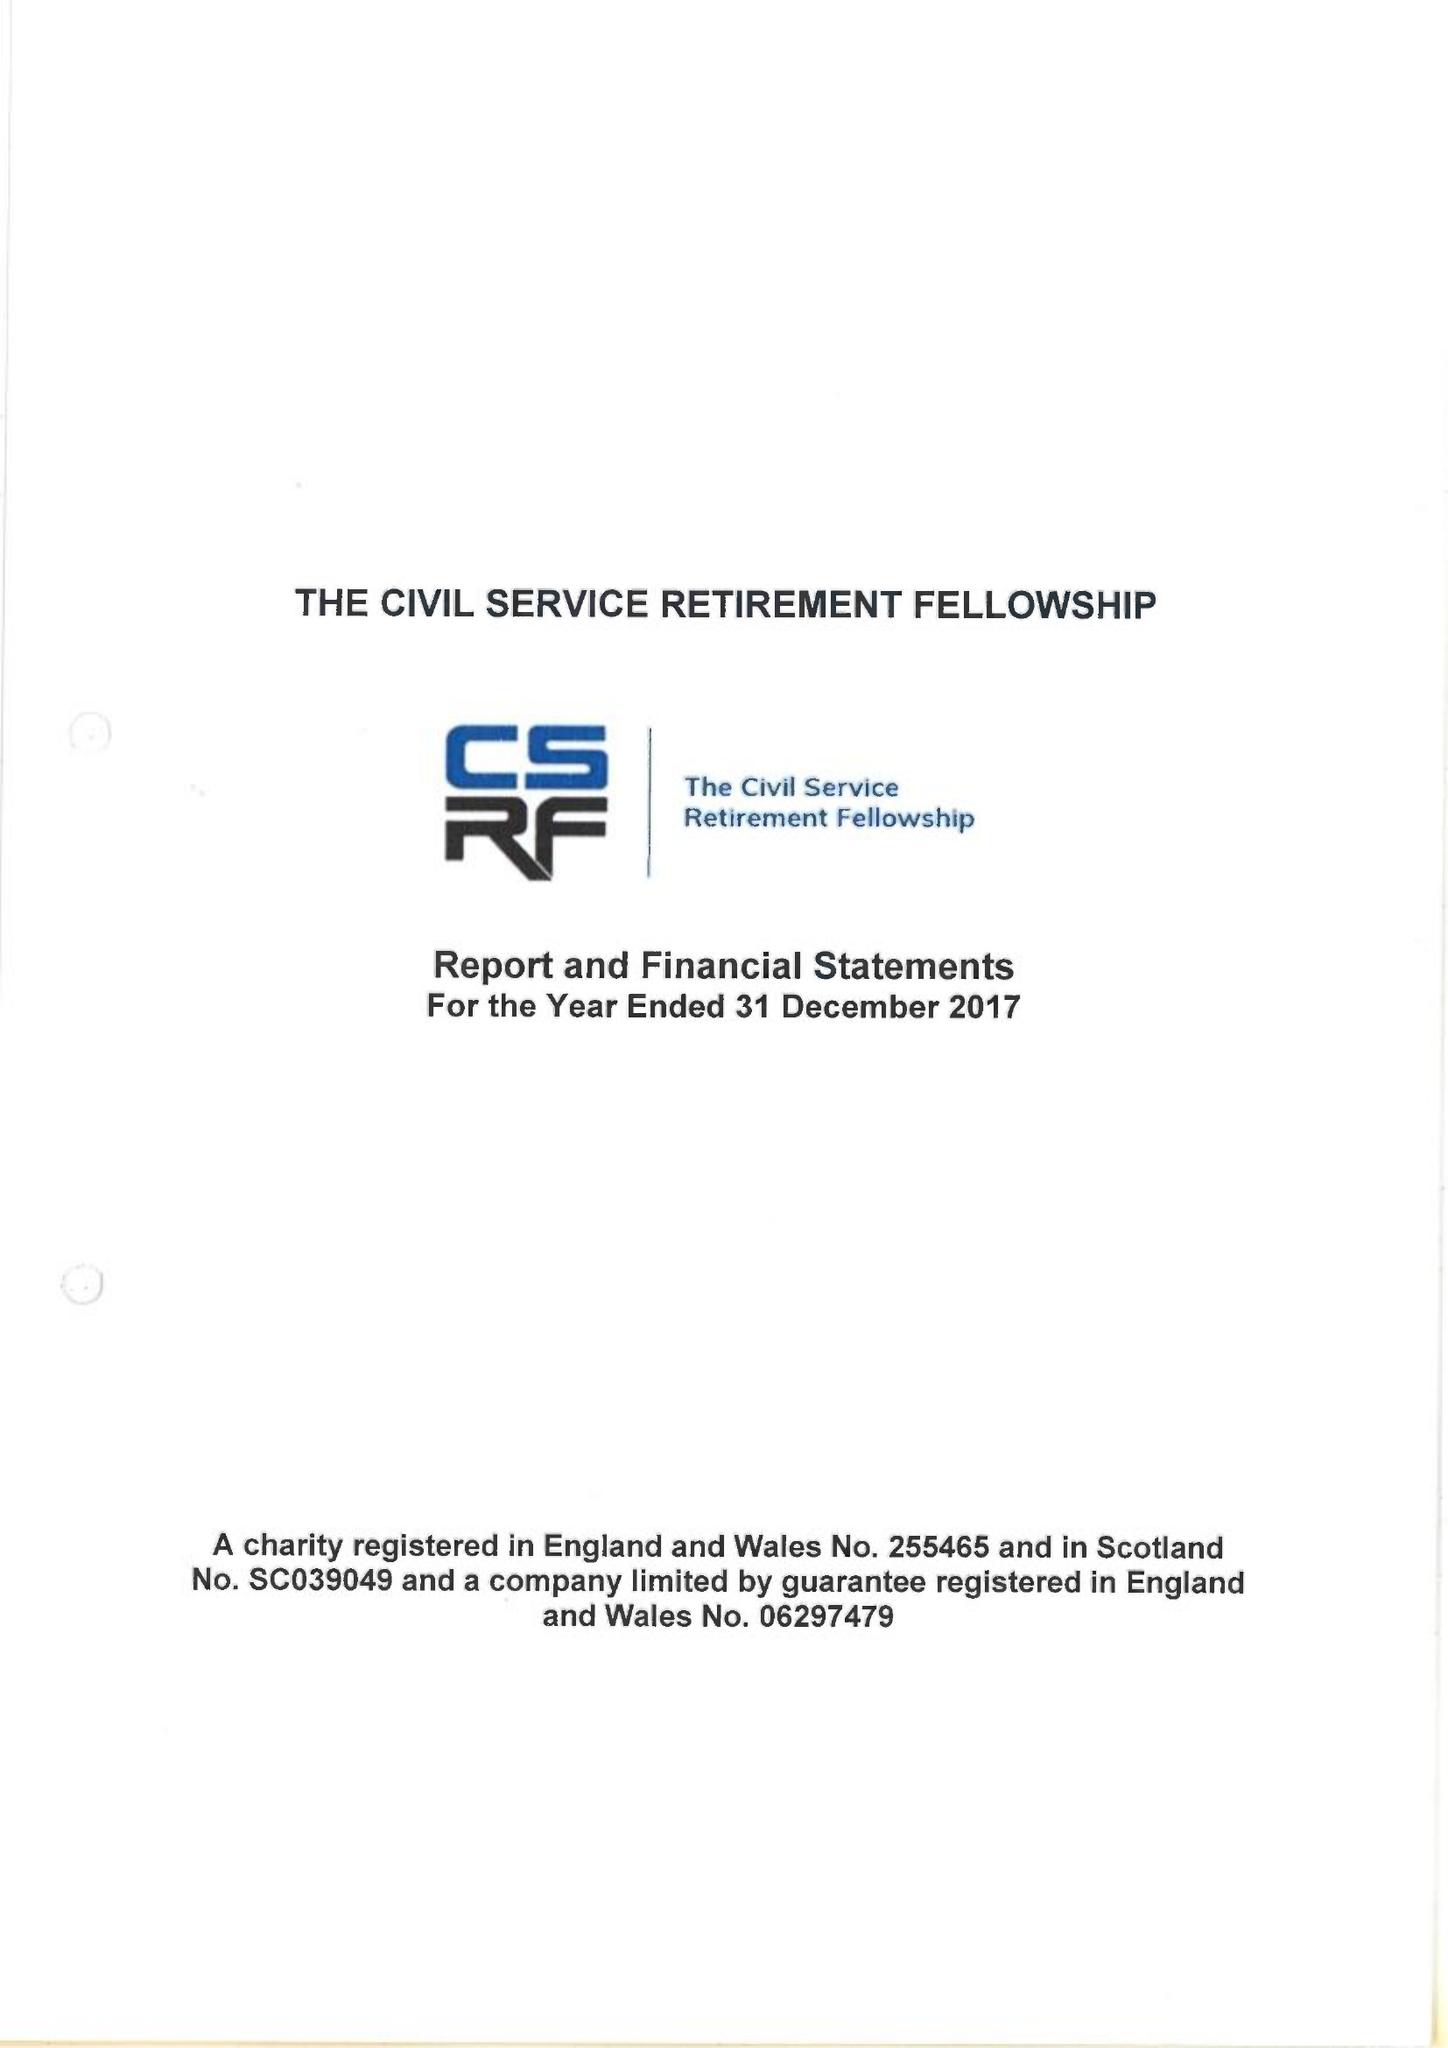What is the value for the address__post_town?
Answer the question using a single word or phrase. LONDON 